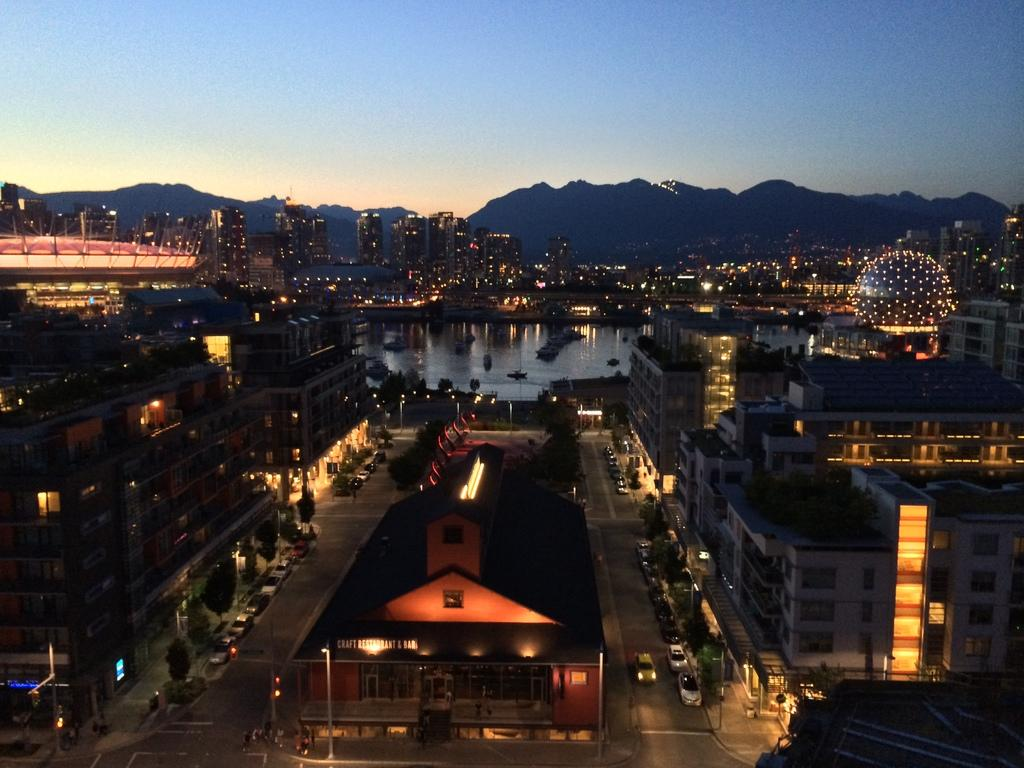What can be seen in the foreground area of the image? In the foreground area of the image, there are buildings, trees, water, and light. What is the composition of the foreground area? The foreground area consists of a mix of natural elements like trees and water, as well as man-made structures like buildings. What is visible in the background of the image? In the background of the image, there are mountains and the sky. What type of dance is the man performing near the mountains in the image? There is no man present in the image, and therefore no dancing can be observed. 